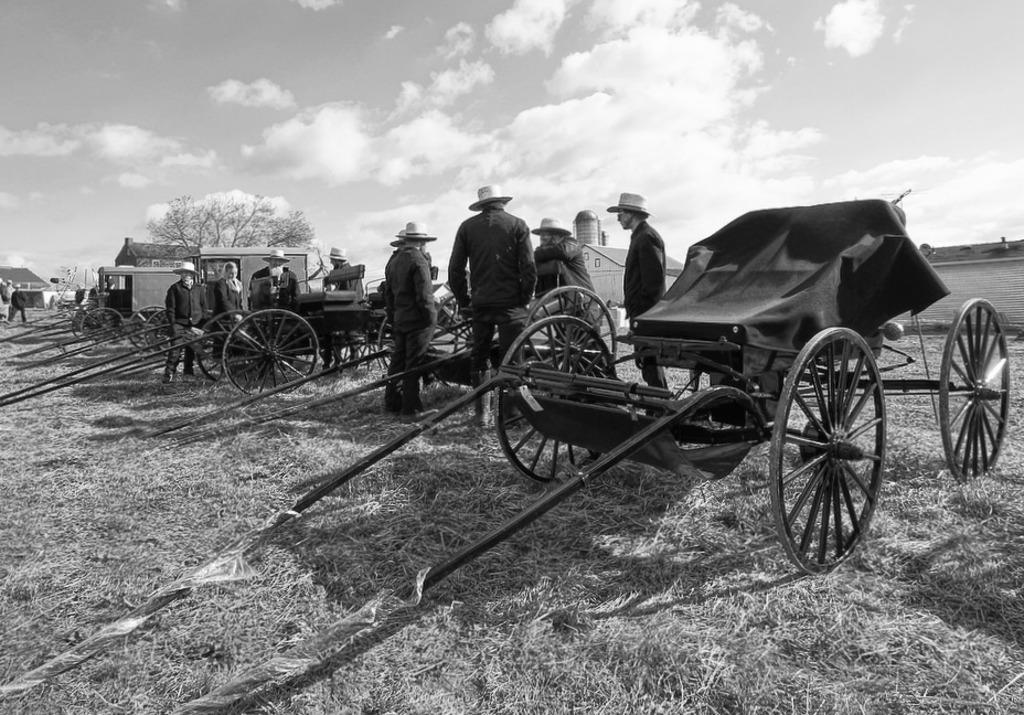What type of ground surface is visible in the image? There is dry grass on the ground in the image. What can be seen in the center of the image? There are persons standing in the center of the image. What type of vehicles are present in the image? There are carts in the image. What type of natural elements are present in the image? There are trees in the image. What type of man-made structures are present in the image? There are buildings in the image. What is the condition of the sky in the image? The sky is cloudy in the image. What type of ice is being used to expand the buildings in the image? There is no ice present in the image, nor is there any indication of expansion of the buildings. 